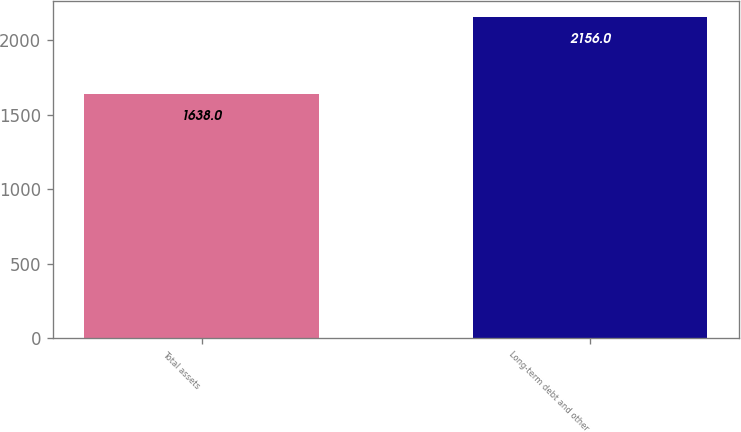Convert chart to OTSL. <chart><loc_0><loc_0><loc_500><loc_500><bar_chart><fcel>Total assets<fcel>Long-term debt and other<nl><fcel>1638<fcel>2156<nl></chart> 